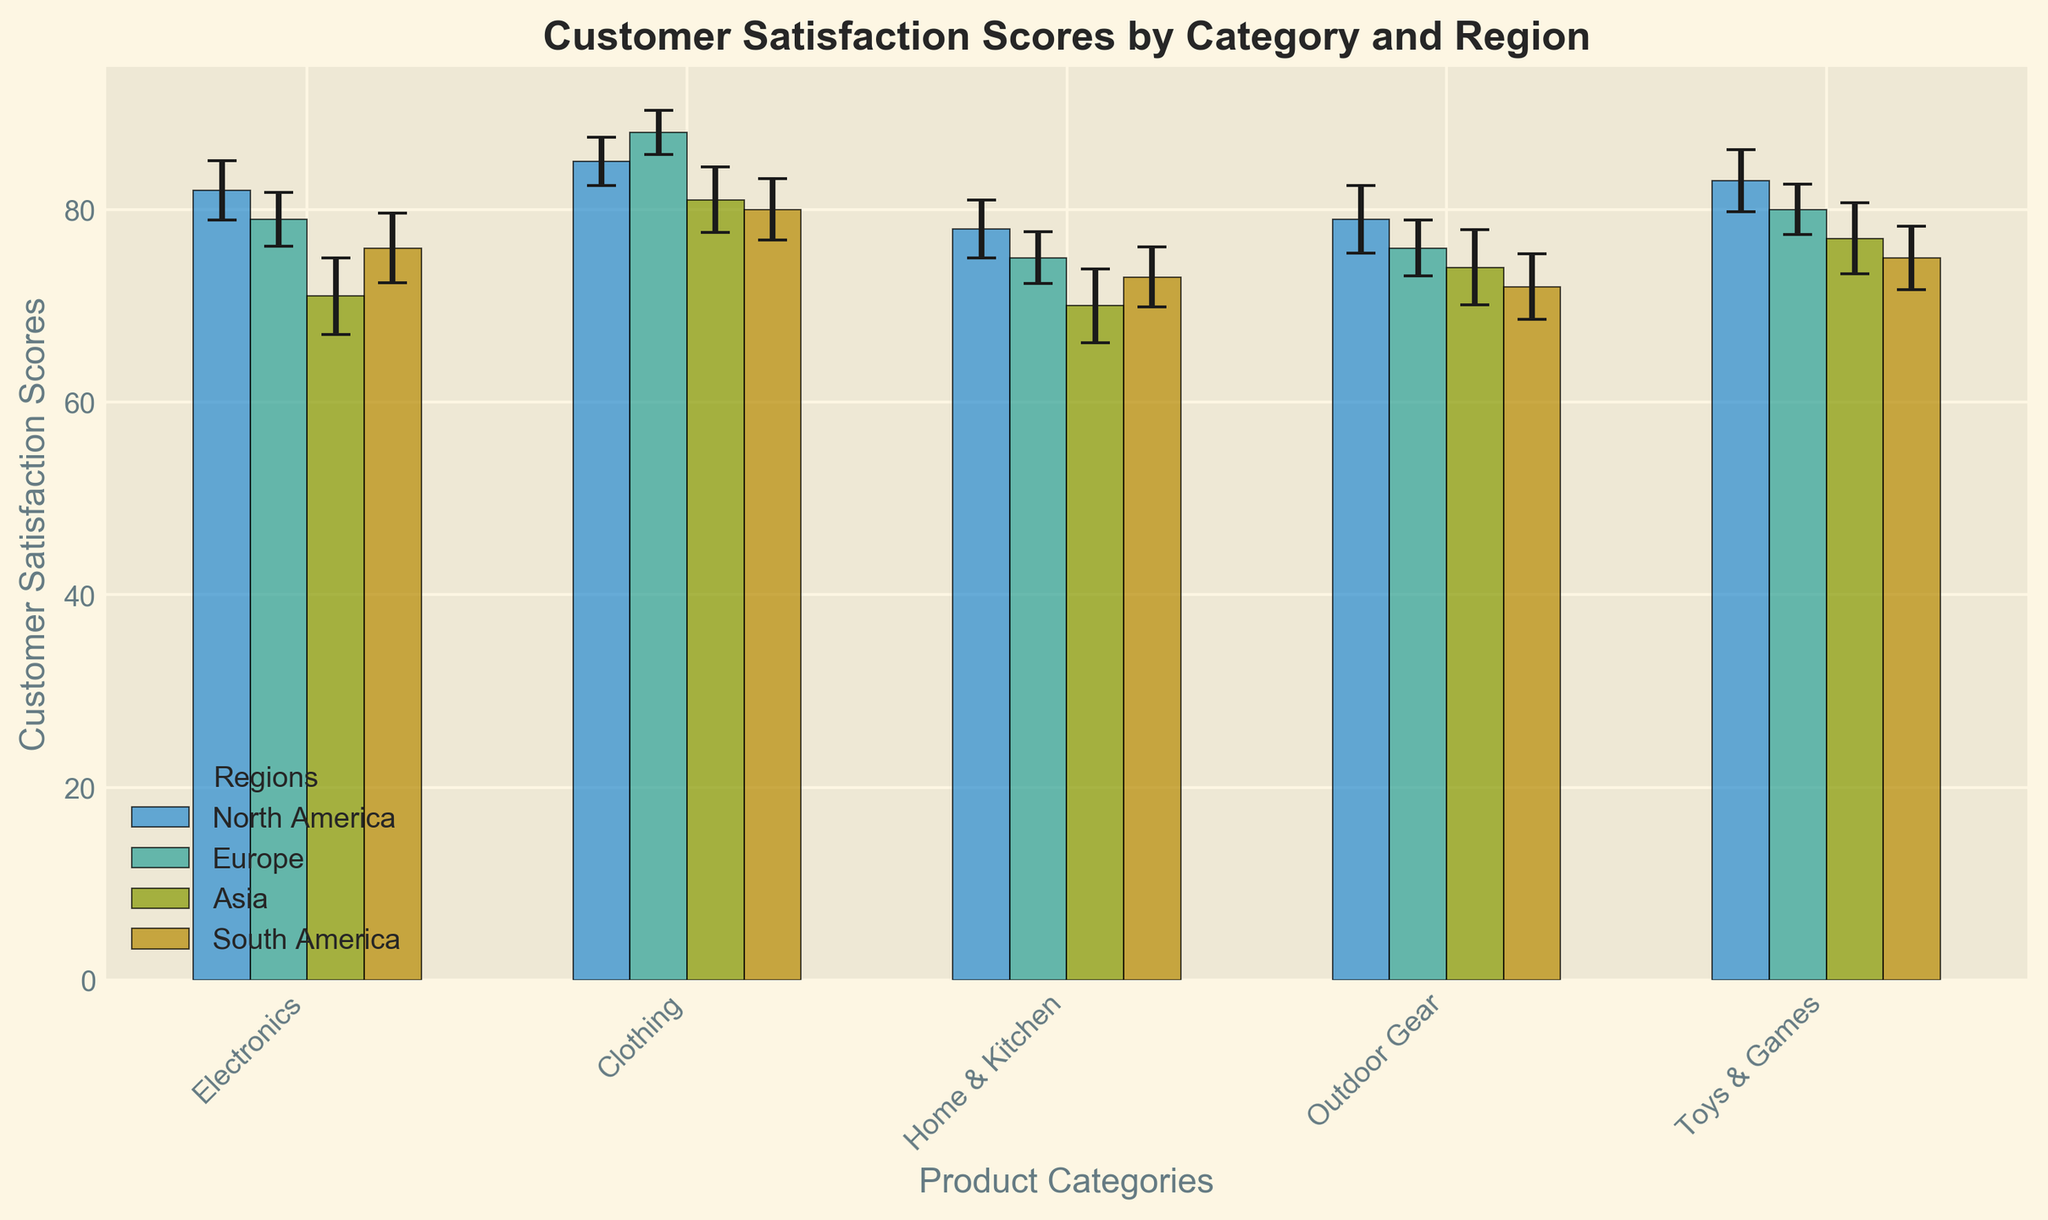What is the average customer satisfaction score for Clothing across all regions? First, find the customer satisfaction scores for Clothing in each region: 85 (North America), 88 (Europe), 81 (Asia), 80 (South America). Sum these scores: 85 + 88 + 81 + 80 = 334. Then, divide by the number of regions: 334 / 4 = 83.5
Answer: 83.5 Which region has the highest customer satisfaction score for Electronics? Look at the heights of the bars for Electronics for each region and find the region with the tallest bar. The scores are 82 (North America), 79 (Europe), 71 (Asia), 76 (South America). North America has the highest score.
Answer: North America Among all the categories, which one has the smallest range of customer satisfaction scores across different regions? Find the range of customer satisfaction scores (max - min) for each category. Electronics: 82 - 71 = 11, Clothing: 88 - 80 = 8, Home & Kitchen: 78 - 70 = 8, Outdoor Gear: 79 - 72 = 7, Toys & Games: 83 - 75 = 8. Outdoor Gear has the smallest range.
Answer: Outdoor Gear Which geographic region has the highest average customer satisfaction score across all categories? Calculate the average customer satisfaction score for each region by summing the scores of all categories and dividing by the number of categories. North America's average: (82 + 85 + 78 + 79 + 83) / 5 = 81.4, Europe: (79 + 88 + 75 + 76 + 80) / 5 = 79.6, Asia: (71 + 81 + 70 + 74 + 77) / 5 = 74.6, South America: (76 + 80 + 73 + 72 + 75) / 5 = 75.2. North America has the highest average.
Answer: North America For Toys & Games, which region has a standard error greater than 3? Find the standard errors for Toys & Games in each region and check which is greater than 3. The errors are: North America (3.2), Europe (2.6), Asia (3.7), South America (3.3). North America, Asia, and South America have errors greater than 3.
Answer: North America, Asia, South America In which product category does Asia have the highest customer satisfaction score? Look at the heights of the bars representing Asia for each product category. The scores are: Electronics (71), Clothing (81), Home & Kitchen (70), Outdoor Gear (74), Toys & Games (77). Clothing has the highest score.
Answer: Clothing Which product category has the smallest standard error for customer satisfaction scores in Europe? Look at the standard errors for each product category in Europe. The errors are: Electronics (2.8), Clothing (2.3), Home & Kitchen (2.7), Outdoor Gear (2.9), Toys & Games (2.6). Clothing has the smallest standard error.
Answer: Clothing Is the customer satisfaction score for Home & Kitchen higher or lower in South America compared to Europe? Compare the heights of the bars for Home & Kitchen in South America and Europe. The scores are 73 (South America) and 75 (Europe). South America's score is lower.
Answer: Lower 